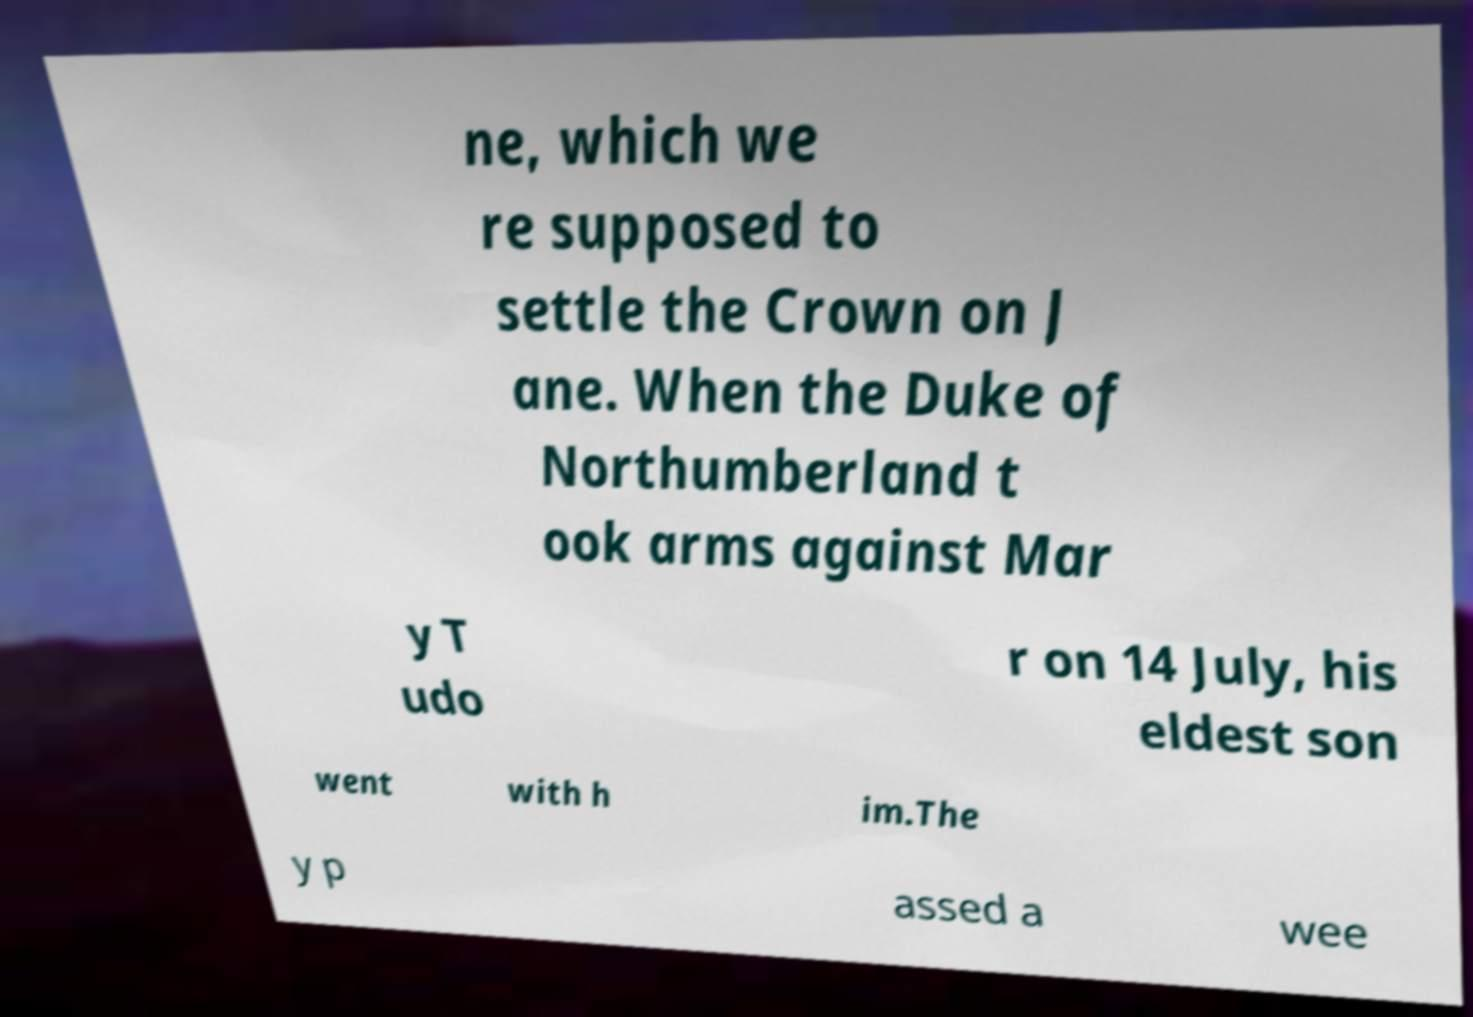There's text embedded in this image that I need extracted. Can you transcribe it verbatim? ne, which we re supposed to settle the Crown on J ane. When the Duke of Northumberland t ook arms against Mar y T udo r on 14 July, his eldest son went with h im.The y p assed a wee 